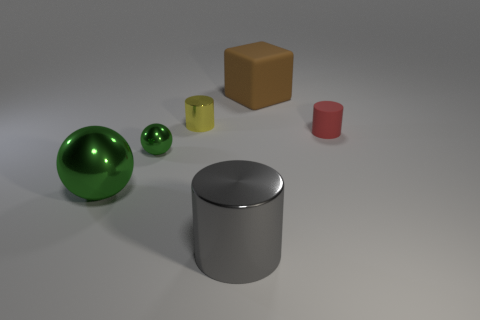Subtract all red cylinders. How many cylinders are left? 2 Subtract all tiny cylinders. How many cylinders are left? 1 Subtract all purple blocks. How many cyan balls are left? 0 Subtract 0 blue cylinders. How many objects are left? 6 Subtract all cubes. How many objects are left? 5 Subtract all purple cylinders. Subtract all cyan spheres. How many cylinders are left? 3 Subtract all small red things. Subtract all small yellow cylinders. How many objects are left? 4 Add 4 small metallic objects. How many small metallic objects are left? 6 Add 3 big brown cubes. How many big brown cubes exist? 4 Add 2 red matte cylinders. How many objects exist? 8 